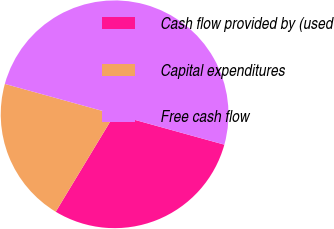Convert chart. <chart><loc_0><loc_0><loc_500><loc_500><pie_chart><fcel>Cash flow provided by (used<fcel>Capital expenditures<fcel>Free cash flow<nl><fcel>29.35%<fcel>20.65%<fcel>50.0%<nl></chart> 